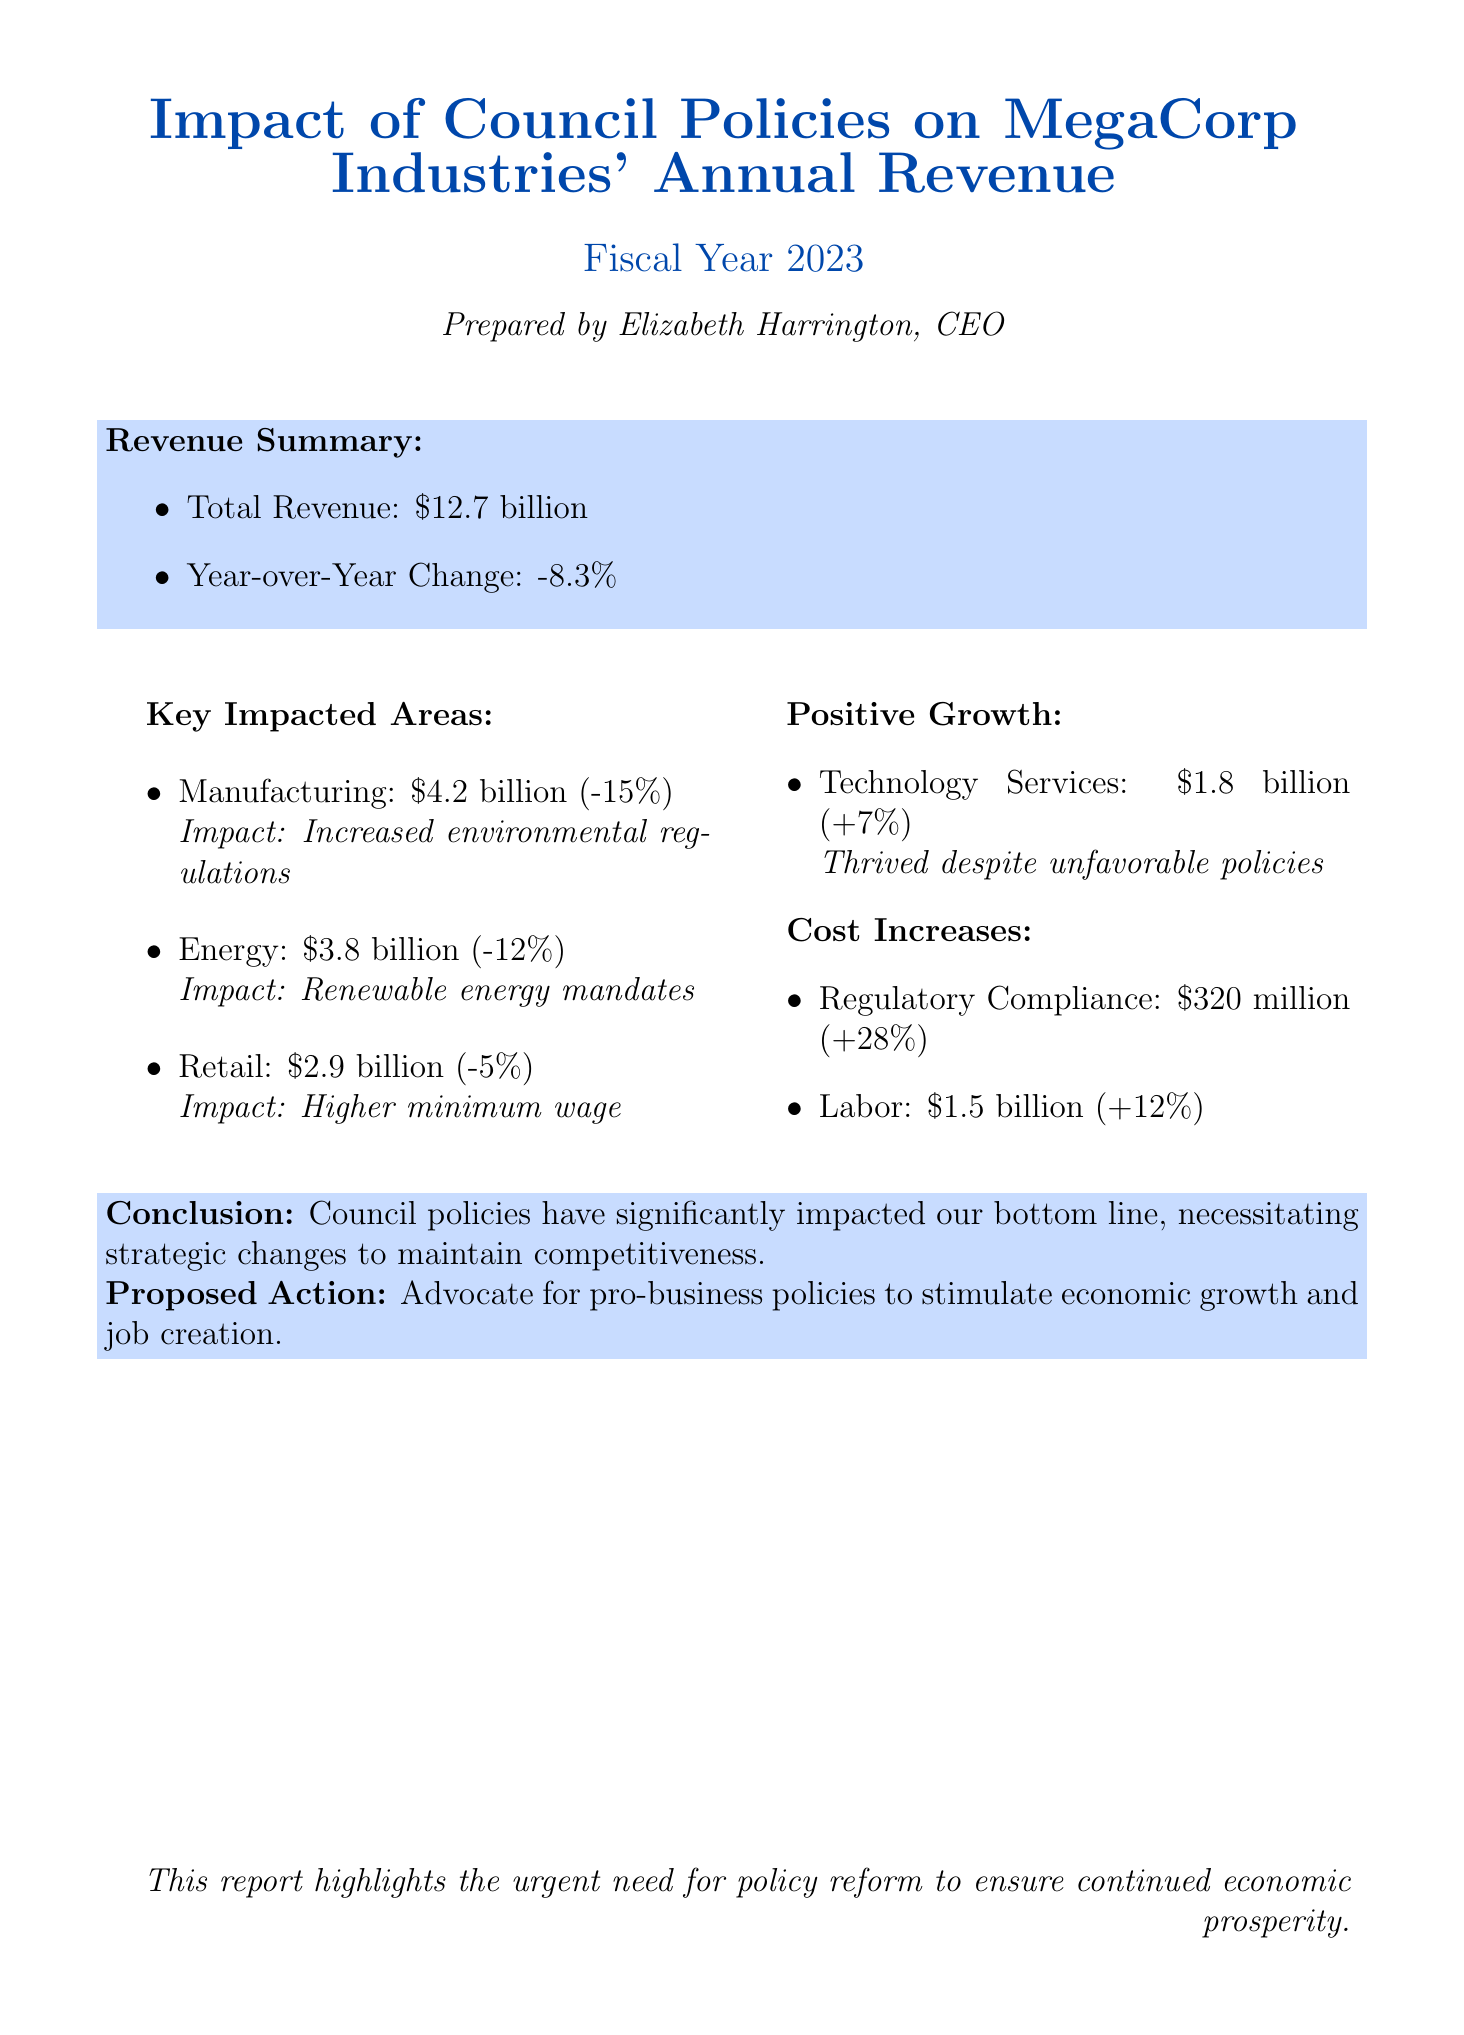What is the total revenue for MegaCorp Industries in 2023? The total revenue is listed in the report summary section under revenue summary.
Answer: $12.7 billion What is the year-over-year change in revenue? The year-over-year change is provided in the revenue summary section, indicating the percentage change from the previous year.
Answer: -8.3% Which sector experienced the highest revenue decline? The sector with the highest revenue decline is mentioned in the key impacted areas, highlighting the sector and its change.
Answer: Manufacturing What is the revenue of the Energy sector? The revenue for the Energy sector is specified in the key impacted areas, detailing its contribution to total revenue.
Answer: $3.8 billion What was the increase in costs related to regulatory compliance? The report provides information regarding cost increases in a specific category, indicating the percentage change.
Answer: $320 million What is the note regarding the Technology Services sector? The report includes a note in the positive growth areas section, expressing the sector's performance despite challenges.
Answer: Thrived despite unfavorable council policies What is the total revenue loss attributed to the Manufacturing sector? The report specifies the revenue change for the Manufacturing sector, detailing the percentage of loss from the previous year.
Answer: -15% What proposed action is mentioned in the conclusion? The conclusion section outlines a proposed action that aims to address current challenges and stimulate growth.
Answer: Advocate for pro-business policies 